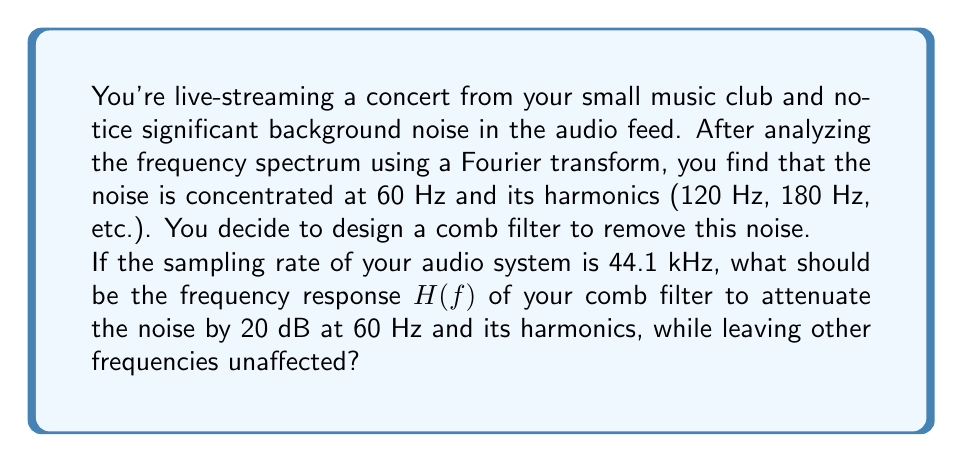Can you solve this math problem? To design a comb filter that attenuates specific frequencies, we need to follow these steps:

1) First, let's recall the general form of a comb filter's frequency response:

   $$H(f) = 1 - \alpha e^{-j2\pi fT}$$

   where $\alpha$ is the attenuation factor, $f$ is the frequency, and $T$ is the delay.

2) We want notches at 60 Hz and its harmonics. The delay $T$ should be the reciprocal of the fundamental frequency:

   $$T = \frac{1}{60 \text{ Hz}} = \frac{1}{60} \text{ seconds}$$

3) To achieve 20 dB attenuation, we need to solve:

   $$20 \log_{10}|H(60)| = -20$$

   $$|H(60)| = 10^{-1} = 0.1$$

4) At 60 Hz (and its harmonics), $e^{-j2\pi fT} = 1$, so:

   $$|H(60)| = |1 - \alpha| = 0.1$$

5) Solving this:

   $$1 - \alpha = 0.1$$
   $$\alpha = 0.9$$

6) Therefore, the frequency response of our comb filter is:

   $$H(f) = 1 - 0.9e^{-j2\pi f(\frac{1}{60})}$$

This filter will create notches at 60 Hz and its harmonics, attenuating these frequencies by 20 dB while leaving other frequencies mostly unaffected.
Answer: $$H(f) = 1 - 0.9e^{-j2\pi f(\frac{1}{60})}$$ 